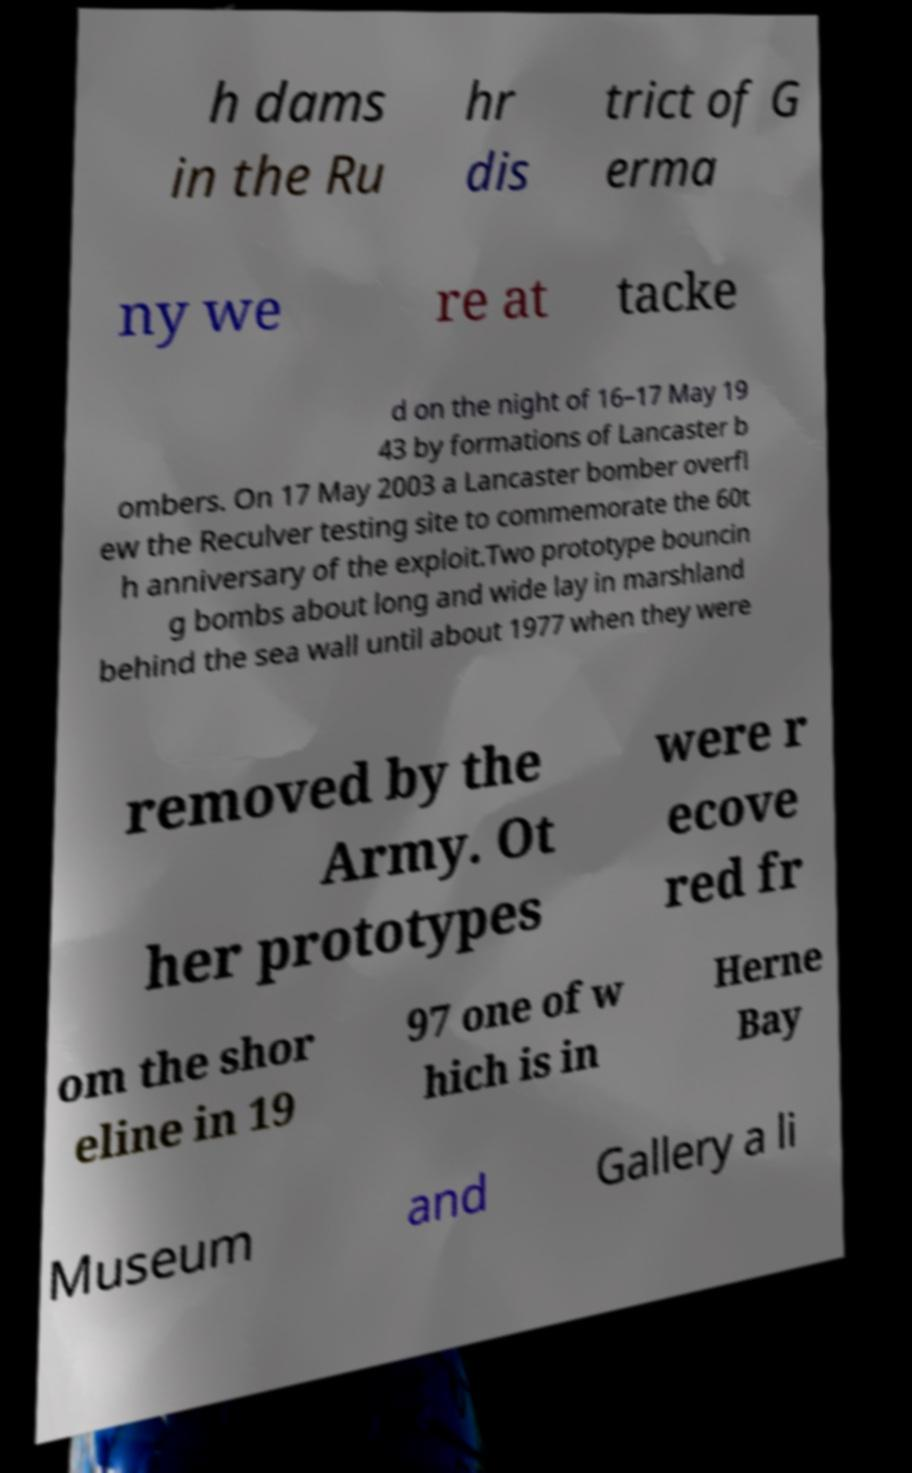I need the written content from this picture converted into text. Can you do that? h dams in the Ru hr dis trict of G erma ny we re at tacke d on the night of 16–17 May 19 43 by formations of Lancaster b ombers. On 17 May 2003 a Lancaster bomber overfl ew the Reculver testing site to commemorate the 60t h anniversary of the exploit.Two prototype bouncin g bombs about long and wide lay in marshland behind the sea wall until about 1977 when they were removed by the Army. Ot her prototypes were r ecove red fr om the shor eline in 19 97 one of w hich is in Herne Bay Museum and Gallery a li 